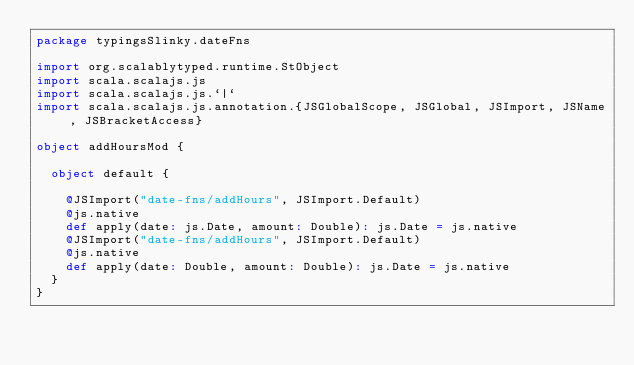<code> <loc_0><loc_0><loc_500><loc_500><_Scala_>package typingsSlinky.dateFns

import org.scalablytyped.runtime.StObject
import scala.scalajs.js
import scala.scalajs.js.`|`
import scala.scalajs.js.annotation.{JSGlobalScope, JSGlobal, JSImport, JSName, JSBracketAccess}

object addHoursMod {
  
  object default {
    
    @JSImport("date-fns/addHours", JSImport.Default)
    @js.native
    def apply(date: js.Date, amount: Double): js.Date = js.native
    @JSImport("date-fns/addHours", JSImport.Default)
    @js.native
    def apply(date: Double, amount: Double): js.Date = js.native
  }
}
</code> 